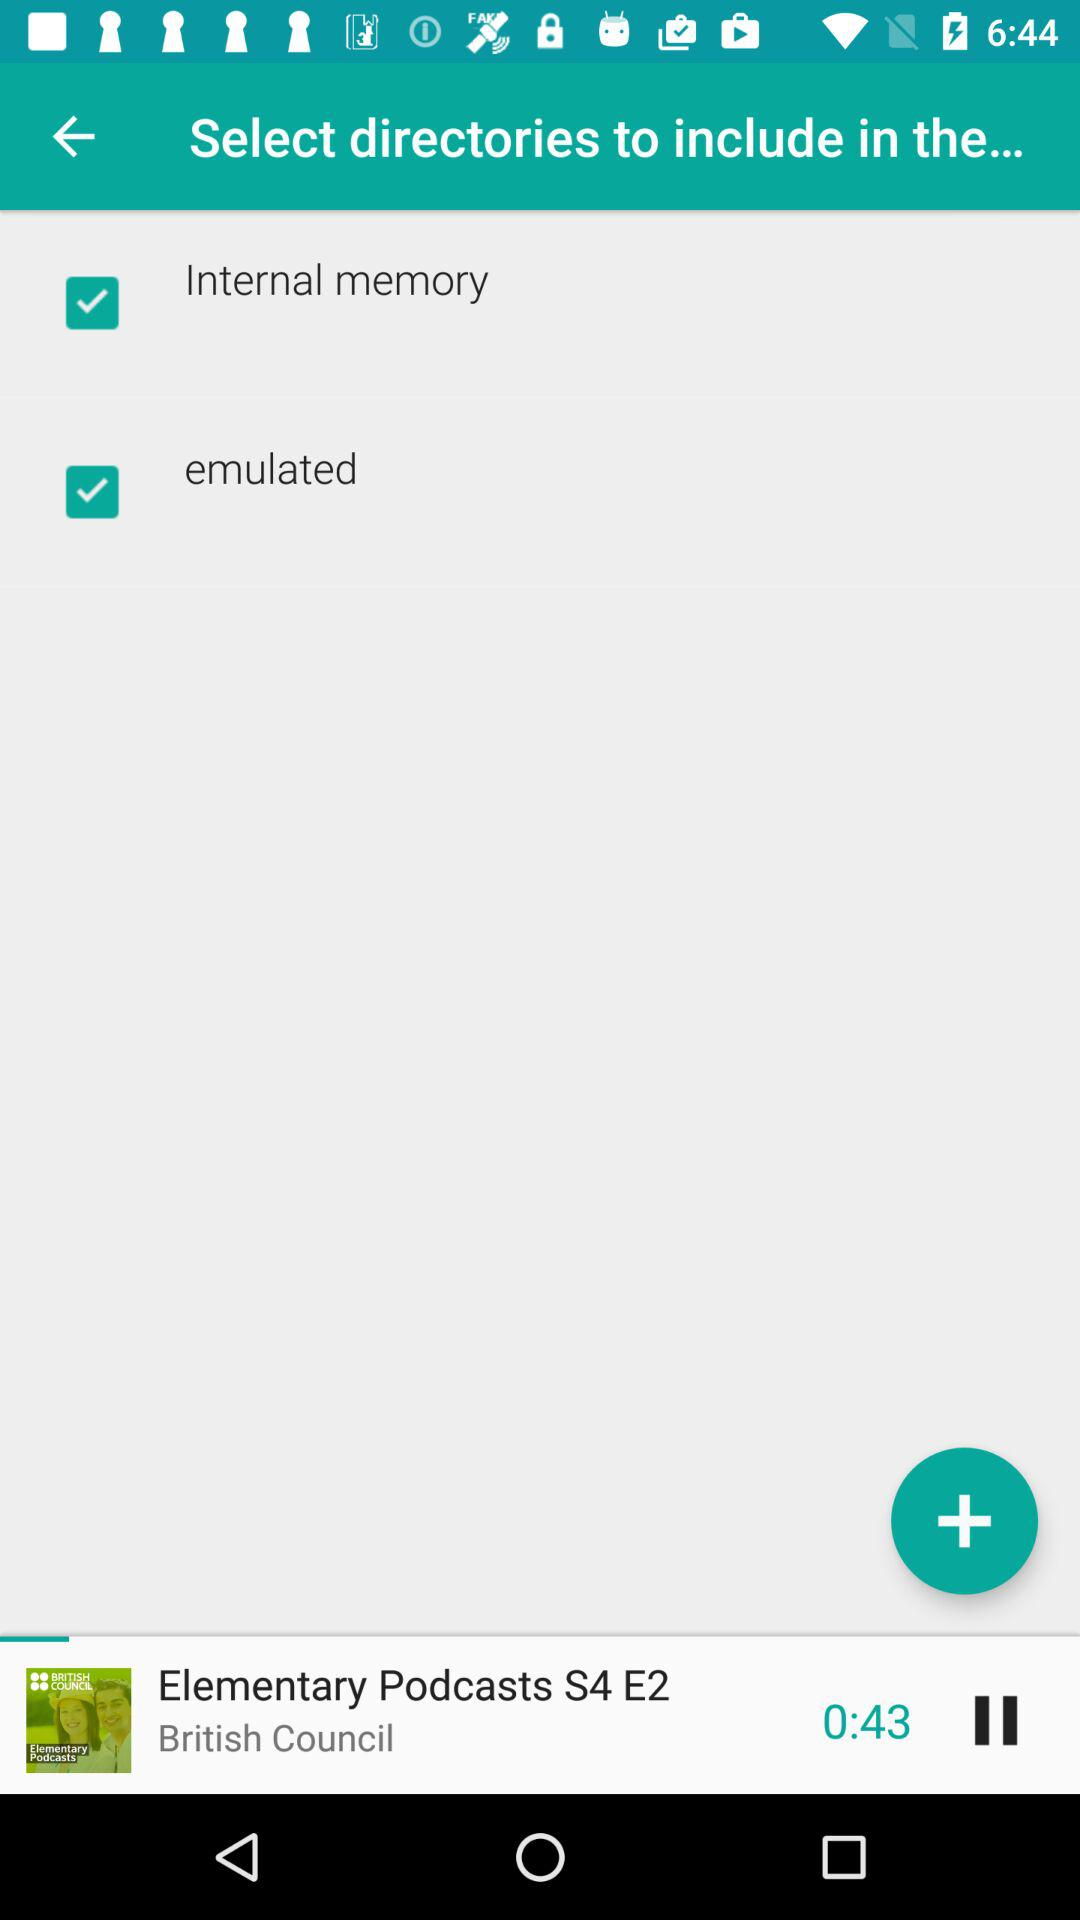Which season of the podcast is playing? The season of the podcast that is currently playing is 4. 